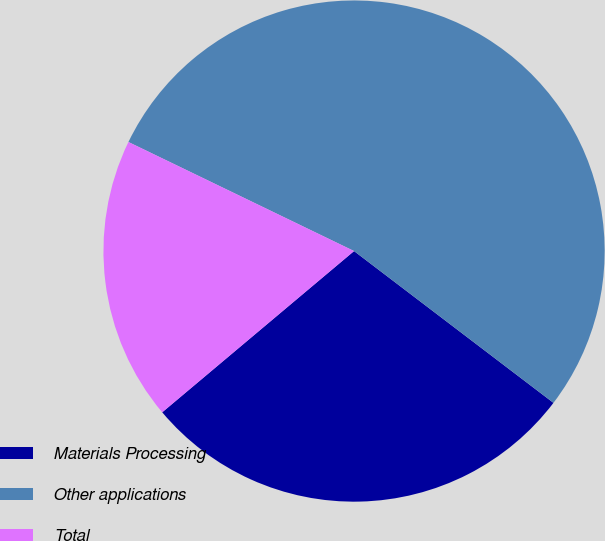Convert chart. <chart><loc_0><loc_0><loc_500><loc_500><pie_chart><fcel>Materials Processing<fcel>Other applications<fcel>Total<nl><fcel>28.52%<fcel>53.19%<fcel>18.29%<nl></chart> 